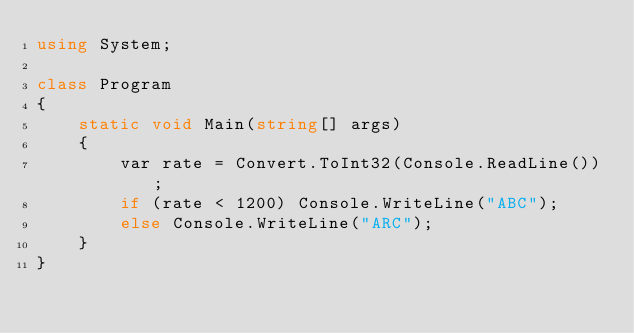Convert code to text. <code><loc_0><loc_0><loc_500><loc_500><_C#_>using System;

class Program
{
    static void Main(string[] args)
    {
        var rate = Convert.ToInt32(Console.ReadLine());
        if (rate < 1200) Console.WriteLine("ABC");
        else Console.WriteLine("ARC");
    }
}</code> 